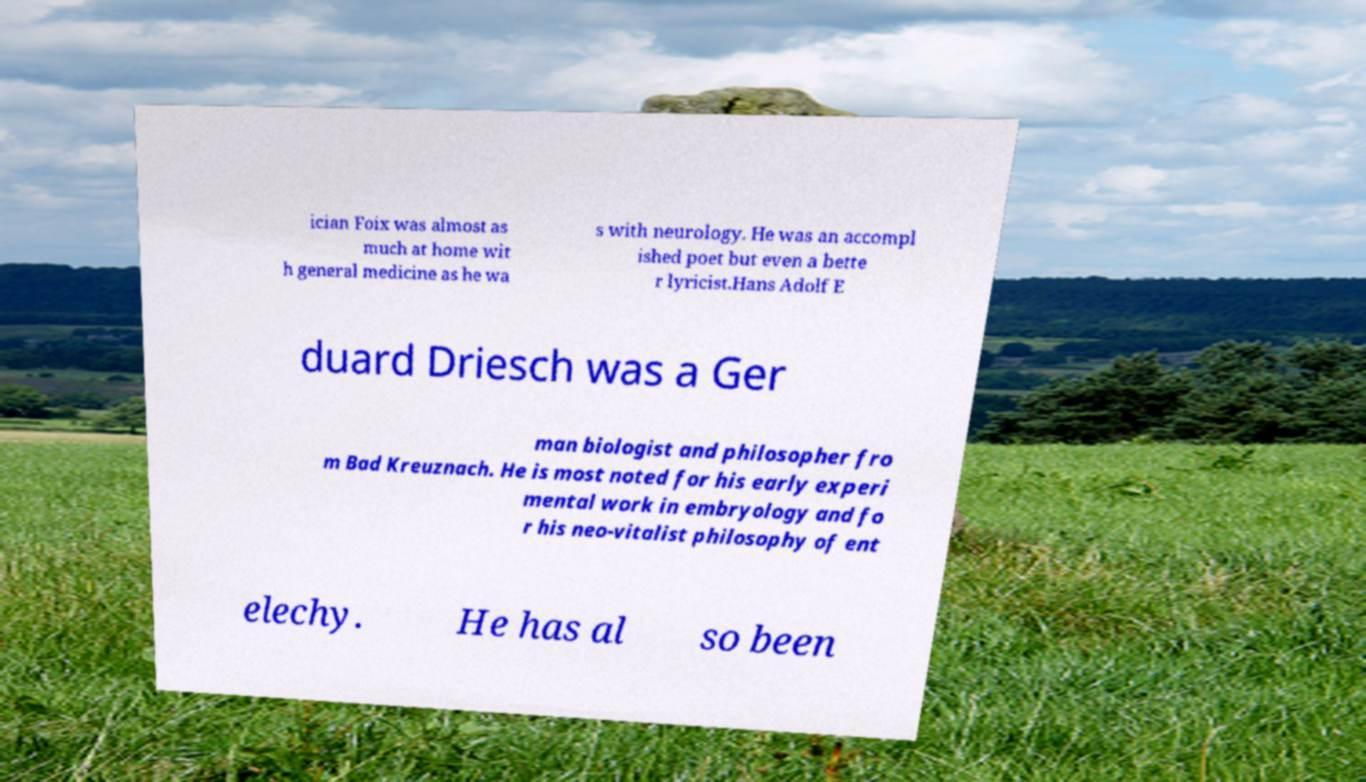Please read and relay the text visible in this image. What does it say? ician Foix was almost as much at home wit h general medicine as he wa s with neurology. He was an accompl ished poet but even a bette r lyricist.Hans Adolf E duard Driesch was a Ger man biologist and philosopher fro m Bad Kreuznach. He is most noted for his early experi mental work in embryology and fo r his neo-vitalist philosophy of ent elechy. He has al so been 